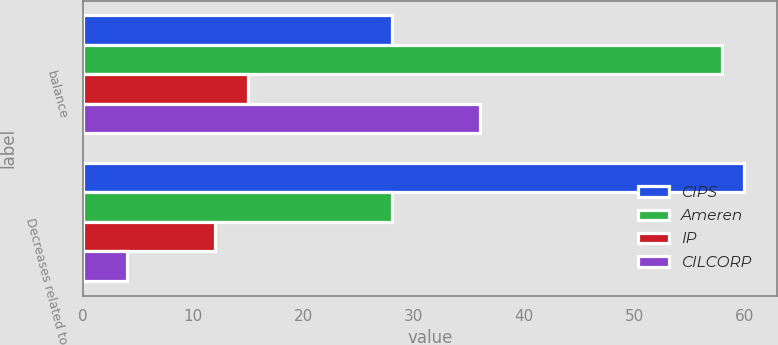Convert chart. <chart><loc_0><loc_0><loc_500><loc_500><stacked_bar_chart><ecel><fcel>balance<fcel>Decreases related to<nl><fcel>CIPS<fcel>28<fcel>60<nl><fcel>Ameren<fcel>58<fcel>28<nl><fcel>IP<fcel>15<fcel>12<nl><fcel>CILCORP<fcel>36<fcel>4<nl></chart> 